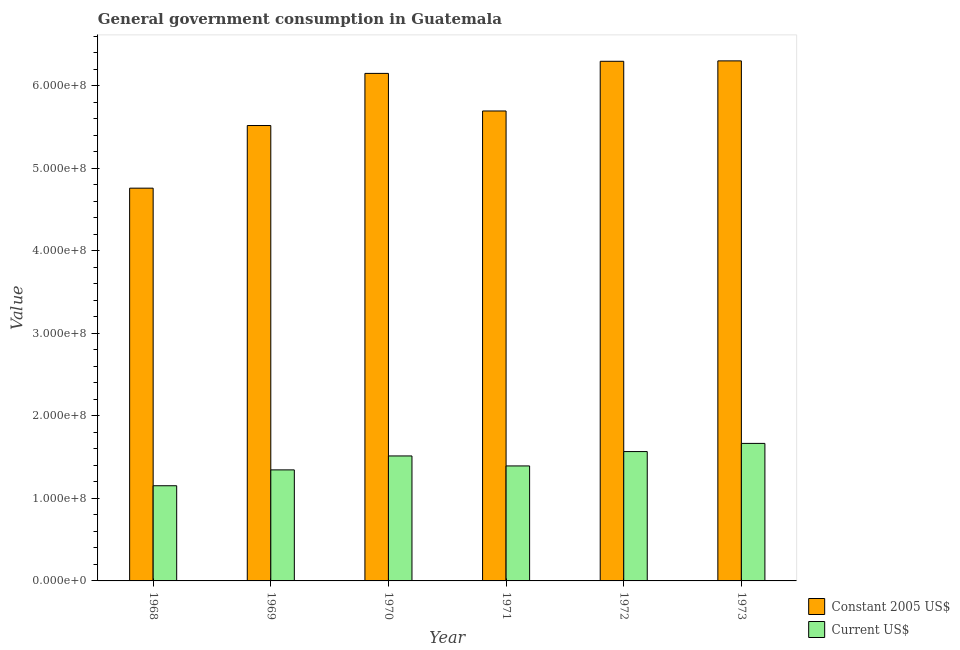Are the number of bars on each tick of the X-axis equal?
Ensure brevity in your answer.  Yes. What is the label of the 2nd group of bars from the left?
Keep it short and to the point. 1969. In how many cases, is the number of bars for a given year not equal to the number of legend labels?
Provide a succinct answer. 0. What is the value consumed in constant 2005 us$ in 1969?
Your answer should be very brief. 5.52e+08. Across all years, what is the maximum value consumed in constant 2005 us$?
Provide a short and direct response. 6.30e+08. Across all years, what is the minimum value consumed in constant 2005 us$?
Your answer should be very brief. 4.76e+08. In which year was the value consumed in constant 2005 us$ maximum?
Keep it short and to the point. 1973. In which year was the value consumed in constant 2005 us$ minimum?
Ensure brevity in your answer.  1968. What is the total value consumed in current us$ in the graph?
Give a very brief answer. 8.64e+08. What is the difference between the value consumed in constant 2005 us$ in 1969 and that in 1972?
Provide a succinct answer. -7.78e+07. What is the difference between the value consumed in constant 2005 us$ in 1969 and the value consumed in current us$ in 1971?
Your response must be concise. -1.76e+07. What is the average value consumed in current us$ per year?
Your answer should be very brief. 1.44e+08. In the year 1968, what is the difference between the value consumed in constant 2005 us$ and value consumed in current us$?
Your answer should be compact. 0. What is the ratio of the value consumed in constant 2005 us$ in 1971 to that in 1972?
Provide a short and direct response. 0.9. Is the difference between the value consumed in constant 2005 us$ in 1970 and 1973 greater than the difference between the value consumed in current us$ in 1970 and 1973?
Provide a short and direct response. No. What is the difference between the highest and the second highest value consumed in current us$?
Your answer should be compact. 9.90e+06. What is the difference between the highest and the lowest value consumed in constant 2005 us$?
Your response must be concise. 1.54e+08. What does the 2nd bar from the left in 1972 represents?
Give a very brief answer. Current US$. What does the 1st bar from the right in 1969 represents?
Provide a succinct answer. Current US$. Are all the bars in the graph horizontal?
Give a very brief answer. No. Does the graph contain any zero values?
Offer a very short reply. No. Does the graph contain grids?
Offer a very short reply. No. How many legend labels are there?
Provide a succinct answer. 2. What is the title of the graph?
Your answer should be very brief. General government consumption in Guatemala. What is the label or title of the X-axis?
Provide a short and direct response. Year. What is the label or title of the Y-axis?
Provide a short and direct response. Value. What is the Value of Constant 2005 US$ in 1968?
Keep it short and to the point. 4.76e+08. What is the Value in Current US$ in 1968?
Provide a succinct answer. 1.15e+08. What is the Value of Constant 2005 US$ in 1969?
Give a very brief answer. 5.52e+08. What is the Value of Current US$ in 1969?
Your answer should be very brief. 1.34e+08. What is the Value in Constant 2005 US$ in 1970?
Provide a short and direct response. 6.15e+08. What is the Value of Current US$ in 1970?
Your answer should be very brief. 1.51e+08. What is the Value of Constant 2005 US$ in 1971?
Ensure brevity in your answer.  5.69e+08. What is the Value of Current US$ in 1971?
Make the answer very short. 1.39e+08. What is the Value of Constant 2005 US$ in 1972?
Ensure brevity in your answer.  6.29e+08. What is the Value of Current US$ in 1972?
Provide a short and direct response. 1.57e+08. What is the Value of Constant 2005 US$ in 1973?
Offer a very short reply. 6.30e+08. What is the Value in Current US$ in 1973?
Your answer should be compact. 1.67e+08. Across all years, what is the maximum Value in Constant 2005 US$?
Ensure brevity in your answer.  6.30e+08. Across all years, what is the maximum Value of Current US$?
Keep it short and to the point. 1.67e+08. Across all years, what is the minimum Value of Constant 2005 US$?
Provide a succinct answer. 4.76e+08. Across all years, what is the minimum Value of Current US$?
Give a very brief answer. 1.15e+08. What is the total Value of Constant 2005 US$ in the graph?
Offer a very short reply. 3.47e+09. What is the total Value of Current US$ in the graph?
Your answer should be very brief. 8.64e+08. What is the difference between the Value in Constant 2005 US$ in 1968 and that in 1969?
Offer a terse response. -7.59e+07. What is the difference between the Value of Current US$ in 1968 and that in 1969?
Your answer should be compact. -1.92e+07. What is the difference between the Value of Constant 2005 US$ in 1968 and that in 1970?
Make the answer very short. -1.39e+08. What is the difference between the Value in Current US$ in 1968 and that in 1970?
Make the answer very short. -3.61e+07. What is the difference between the Value of Constant 2005 US$ in 1968 and that in 1971?
Your response must be concise. -9.35e+07. What is the difference between the Value in Current US$ in 1968 and that in 1971?
Provide a short and direct response. -2.40e+07. What is the difference between the Value of Constant 2005 US$ in 1968 and that in 1972?
Ensure brevity in your answer.  -1.54e+08. What is the difference between the Value in Current US$ in 1968 and that in 1972?
Provide a short and direct response. -4.14e+07. What is the difference between the Value in Constant 2005 US$ in 1968 and that in 1973?
Provide a succinct answer. -1.54e+08. What is the difference between the Value in Current US$ in 1968 and that in 1973?
Ensure brevity in your answer.  -5.13e+07. What is the difference between the Value of Constant 2005 US$ in 1969 and that in 1970?
Provide a short and direct response. -6.31e+07. What is the difference between the Value in Current US$ in 1969 and that in 1970?
Offer a very short reply. -1.69e+07. What is the difference between the Value of Constant 2005 US$ in 1969 and that in 1971?
Offer a terse response. -1.76e+07. What is the difference between the Value in Current US$ in 1969 and that in 1971?
Make the answer very short. -4.80e+06. What is the difference between the Value of Constant 2005 US$ in 1969 and that in 1972?
Provide a succinct answer. -7.78e+07. What is the difference between the Value of Current US$ in 1969 and that in 1972?
Provide a succinct answer. -2.22e+07. What is the difference between the Value in Constant 2005 US$ in 1969 and that in 1973?
Make the answer very short. -7.83e+07. What is the difference between the Value in Current US$ in 1969 and that in 1973?
Offer a terse response. -3.21e+07. What is the difference between the Value of Constant 2005 US$ in 1970 and that in 1971?
Your response must be concise. 4.55e+07. What is the difference between the Value of Current US$ in 1970 and that in 1971?
Provide a succinct answer. 1.21e+07. What is the difference between the Value of Constant 2005 US$ in 1970 and that in 1972?
Give a very brief answer. -1.47e+07. What is the difference between the Value of Current US$ in 1970 and that in 1972?
Offer a very short reply. -5.30e+06. What is the difference between the Value in Constant 2005 US$ in 1970 and that in 1973?
Offer a terse response. -1.52e+07. What is the difference between the Value in Current US$ in 1970 and that in 1973?
Your answer should be compact. -1.52e+07. What is the difference between the Value in Constant 2005 US$ in 1971 and that in 1972?
Provide a short and direct response. -6.02e+07. What is the difference between the Value of Current US$ in 1971 and that in 1972?
Provide a succinct answer. -1.74e+07. What is the difference between the Value in Constant 2005 US$ in 1971 and that in 1973?
Your answer should be very brief. -6.07e+07. What is the difference between the Value of Current US$ in 1971 and that in 1973?
Give a very brief answer. -2.73e+07. What is the difference between the Value in Constant 2005 US$ in 1972 and that in 1973?
Ensure brevity in your answer.  -4.89e+05. What is the difference between the Value of Current US$ in 1972 and that in 1973?
Give a very brief answer. -9.90e+06. What is the difference between the Value of Constant 2005 US$ in 1968 and the Value of Current US$ in 1969?
Offer a terse response. 3.41e+08. What is the difference between the Value in Constant 2005 US$ in 1968 and the Value in Current US$ in 1970?
Make the answer very short. 3.24e+08. What is the difference between the Value of Constant 2005 US$ in 1968 and the Value of Current US$ in 1971?
Provide a succinct answer. 3.36e+08. What is the difference between the Value of Constant 2005 US$ in 1968 and the Value of Current US$ in 1972?
Give a very brief answer. 3.19e+08. What is the difference between the Value in Constant 2005 US$ in 1968 and the Value in Current US$ in 1973?
Provide a short and direct response. 3.09e+08. What is the difference between the Value in Constant 2005 US$ in 1969 and the Value in Current US$ in 1970?
Ensure brevity in your answer.  4.00e+08. What is the difference between the Value in Constant 2005 US$ in 1969 and the Value in Current US$ in 1971?
Your answer should be compact. 4.12e+08. What is the difference between the Value of Constant 2005 US$ in 1969 and the Value of Current US$ in 1972?
Provide a succinct answer. 3.95e+08. What is the difference between the Value in Constant 2005 US$ in 1969 and the Value in Current US$ in 1973?
Offer a terse response. 3.85e+08. What is the difference between the Value in Constant 2005 US$ in 1970 and the Value in Current US$ in 1971?
Your response must be concise. 4.75e+08. What is the difference between the Value in Constant 2005 US$ in 1970 and the Value in Current US$ in 1972?
Your response must be concise. 4.58e+08. What is the difference between the Value of Constant 2005 US$ in 1970 and the Value of Current US$ in 1973?
Your answer should be compact. 4.48e+08. What is the difference between the Value in Constant 2005 US$ in 1971 and the Value in Current US$ in 1972?
Your answer should be compact. 4.13e+08. What is the difference between the Value in Constant 2005 US$ in 1971 and the Value in Current US$ in 1973?
Give a very brief answer. 4.03e+08. What is the difference between the Value in Constant 2005 US$ in 1972 and the Value in Current US$ in 1973?
Your response must be concise. 4.63e+08. What is the average Value in Constant 2005 US$ per year?
Provide a short and direct response. 5.78e+08. What is the average Value of Current US$ per year?
Make the answer very short. 1.44e+08. In the year 1968, what is the difference between the Value in Constant 2005 US$ and Value in Current US$?
Give a very brief answer. 3.60e+08. In the year 1969, what is the difference between the Value in Constant 2005 US$ and Value in Current US$?
Make the answer very short. 4.17e+08. In the year 1970, what is the difference between the Value of Constant 2005 US$ and Value of Current US$?
Give a very brief answer. 4.63e+08. In the year 1971, what is the difference between the Value of Constant 2005 US$ and Value of Current US$?
Give a very brief answer. 4.30e+08. In the year 1972, what is the difference between the Value in Constant 2005 US$ and Value in Current US$?
Make the answer very short. 4.73e+08. In the year 1973, what is the difference between the Value of Constant 2005 US$ and Value of Current US$?
Provide a succinct answer. 4.63e+08. What is the ratio of the Value of Constant 2005 US$ in 1968 to that in 1969?
Keep it short and to the point. 0.86. What is the ratio of the Value of Current US$ in 1968 to that in 1969?
Give a very brief answer. 0.86. What is the ratio of the Value of Constant 2005 US$ in 1968 to that in 1970?
Ensure brevity in your answer.  0.77. What is the ratio of the Value in Current US$ in 1968 to that in 1970?
Your answer should be very brief. 0.76. What is the ratio of the Value of Constant 2005 US$ in 1968 to that in 1971?
Give a very brief answer. 0.84. What is the ratio of the Value of Current US$ in 1968 to that in 1971?
Ensure brevity in your answer.  0.83. What is the ratio of the Value in Constant 2005 US$ in 1968 to that in 1972?
Your answer should be very brief. 0.76. What is the ratio of the Value of Current US$ in 1968 to that in 1972?
Provide a short and direct response. 0.74. What is the ratio of the Value in Constant 2005 US$ in 1968 to that in 1973?
Offer a very short reply. 0.76. What is the ratio of the Value of Current US$ in 1968 to that in 1973?
Provide a short and direct response. 0.69. What is the ratio of the Value in Constant 2005 US$ in 1969 to that in 1970?
Make the answer very short. 0.9. What is the ratio of the Value in Current US$ in 1969 to that in 1970?
Offer a very short reply. 0.89. What is the ratio of the Value in Current US$ in 1969 to that in 1971?
Your answer should be compact. 0.97. What is the ratio of the Value in Constant 2005 US$ in 1969 to that in 1972?
Offer a very short reply. 0.88. What is the ratio of the Value of Current US$ in 1969 to that in 1972?
Your answer should be compact. 0.86. What is the ratio of the Value in Constant 2005 US$ in 1969 to that in 1973?
Your response must be concise. 0.88. What is the ratio of the Value in Current US$ in 1969 to that in 1973?
Provide a short and direct response. 0.81. What is the ratio of the Value of Constant 2005 US$ in 1970 to that in 1971?
Provide a short and direct response. 1.08. What is the ratio of the Value of Current US$ in 1970 to that in 1971?
Your response must be concise. 1.09. What is the ratio of the Value of Constant 2005 US$ in 1970 to that in 1972?
Your answer should be very brief. 0.98. What is the ratio of the Value of Current US$ in 1970 to that in 1972?
Provide a short and direct response. 0.97. What is the ratio of the Value of Constant 2005 US$ in 1970 to that in 1973?
Give a very brief answer. 0.98. What is the ratio of the Value in Current US$ in 1970 to that in 1973?
Provide a succinct answer. 0.91. What is the ratio of the Value of Constant 2005 US$ in 1971 to that in 1972?
Offer a very short reply. 0.9. What is the ratio of the Value in Current US$ in 1971 to that in 1972?
Offer a very short reply. 0.89. What is the ratio of the Value in Constant 2005 US$ in 1971 to that in 1973?
Offer a terse response. 0.9. What is the ratio of the Value in Current US$ in 1971 to that in 1973?
Give a very brief answer. 0.84. What is the ratio of the Value in Constant 2005 US$ in 1972 to that in 1973?
Offer a very short reply. 1. What is the ratio of the Value in Current US$ in 1972 to that in 1973?
Keep it short and to the point. 0.94. What is the difference between the highest and the second highest Value of Constant 2005 US$?
Offer a terse response. 4.89e+05. What is the difference between the highest and the second highest Value of Current US$?
Offer a terse response. 9.90e+06. What is the difference between the highest and the lowest Value in Constant 2005 US$?
Your answer should be very brief. 1.54e+08. What is the difference between the highest and the lowest Value of Current US$?
Your answer should be compact. 5.13e+07. 